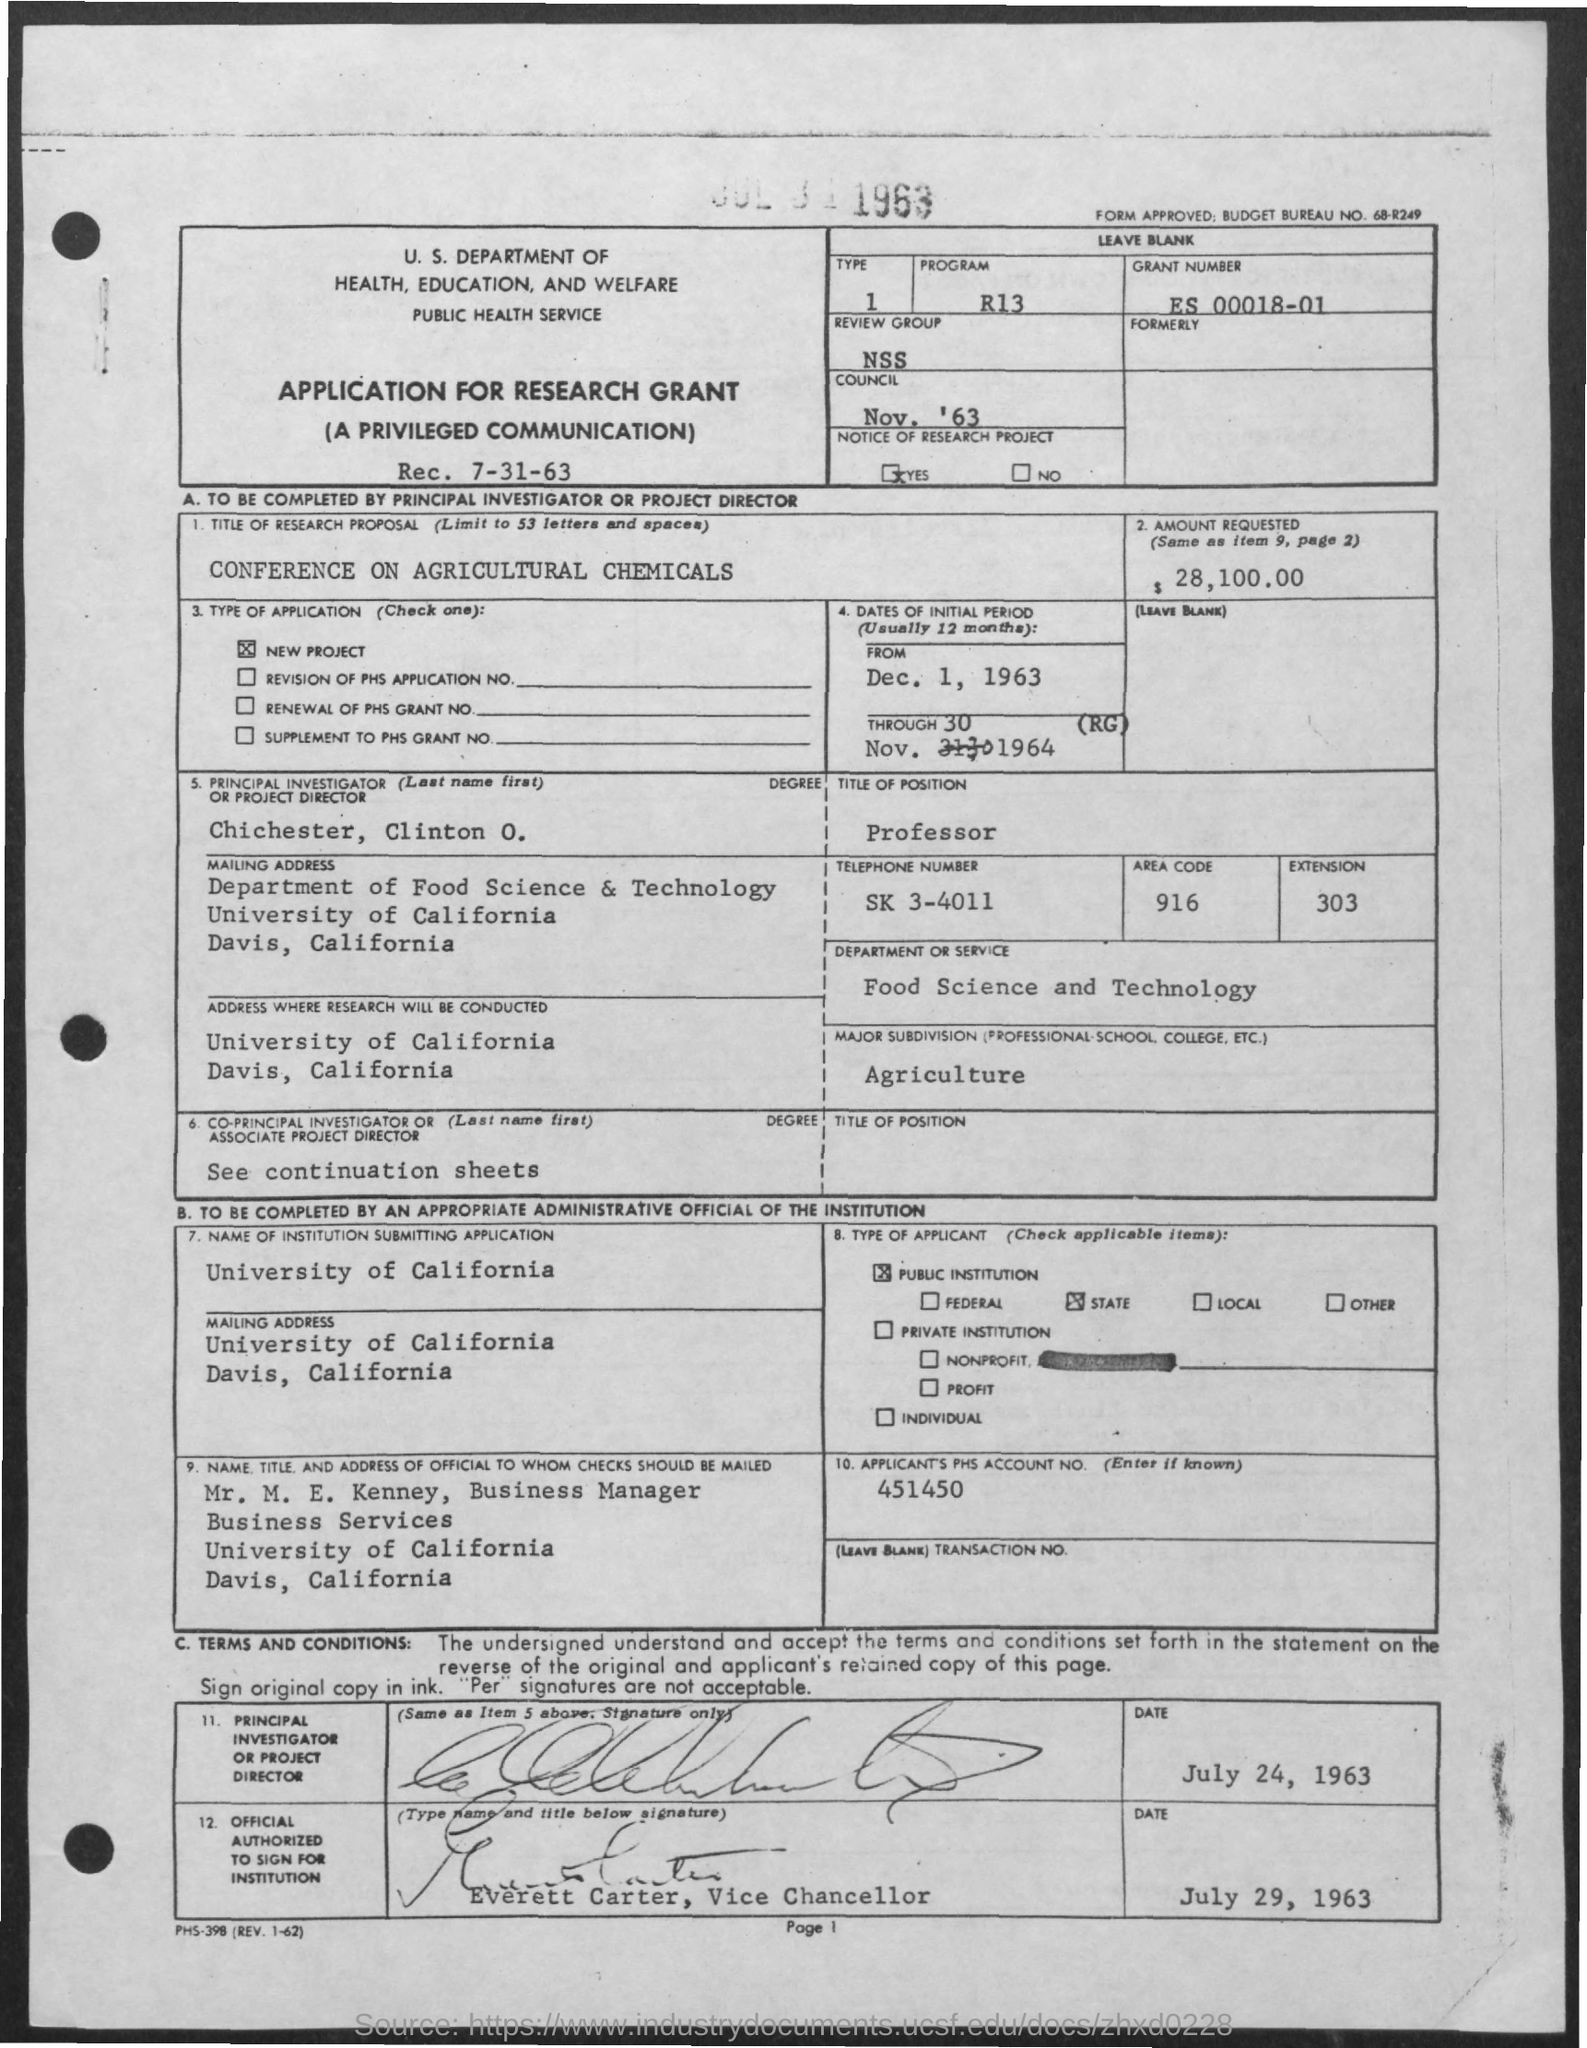Draw attention to some important aspects in this diagram. The Grant Number mentioned in the application is ES 00018-01. The position of Chichester, Clinton O. in the application is titled "Professor. The individual to whom the checks should be mailed is named Mr. M. E. Kenney. The applicant's PHS Account No. as provided in the application is 451450. The principal investigator or project director in the application is Chichester, Clinton O. 